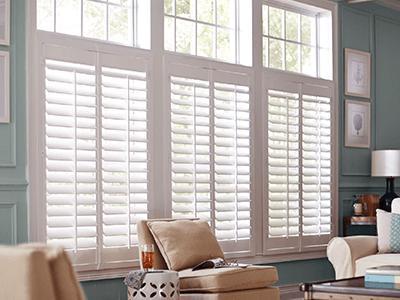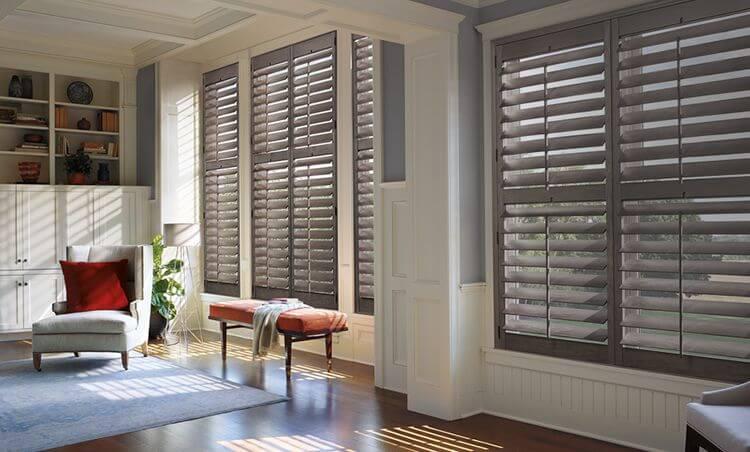The first image is the image on the left, the second image is the image on the right. Assess this claim about the two images: "There are six blinds or window coverings.". Correct or not? Answer yes or no. No. 